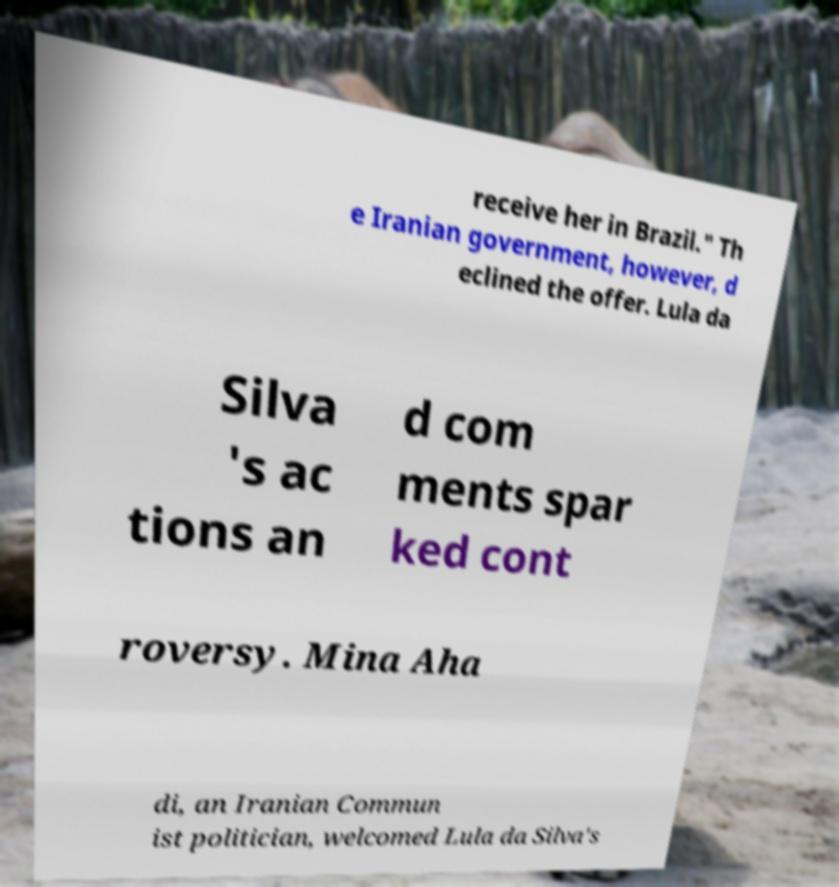There's text embedded in this image that I need extracted. Can you transcribe it verbatim? receive her in Brazil." Th e Iranian government, however, d eclined the offer. Lula da Silva 's ac tions an d com ments spar ked cont roversy. Mina Aha di, an Iranian Commun ist politician, welcomed Lula da Silva's 